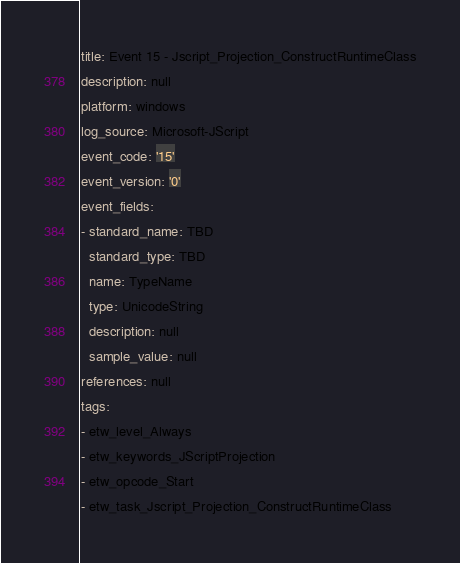<code> <loc_0><loc_0><loc_500><loc_500><_YAML_>title: Event 15 - Jscript_Projection_ConstructRuntimeClass
description: null
platform: windows
log_source: Microsoft-JScript
event_code: '15'
event_version: '0'
event_fields:
- standard_name: TBD
  standard_type: TBD
  name: TypeName
  type: UnicodeString
  description: null
  sample_value: null
references: null
tags:
- etw_level_Always
- etw_keywords_JScriptProjection
- etw_opcode_Start
- etw_task_Jscript_Projection_ConstructRuntimeClass
</code> 